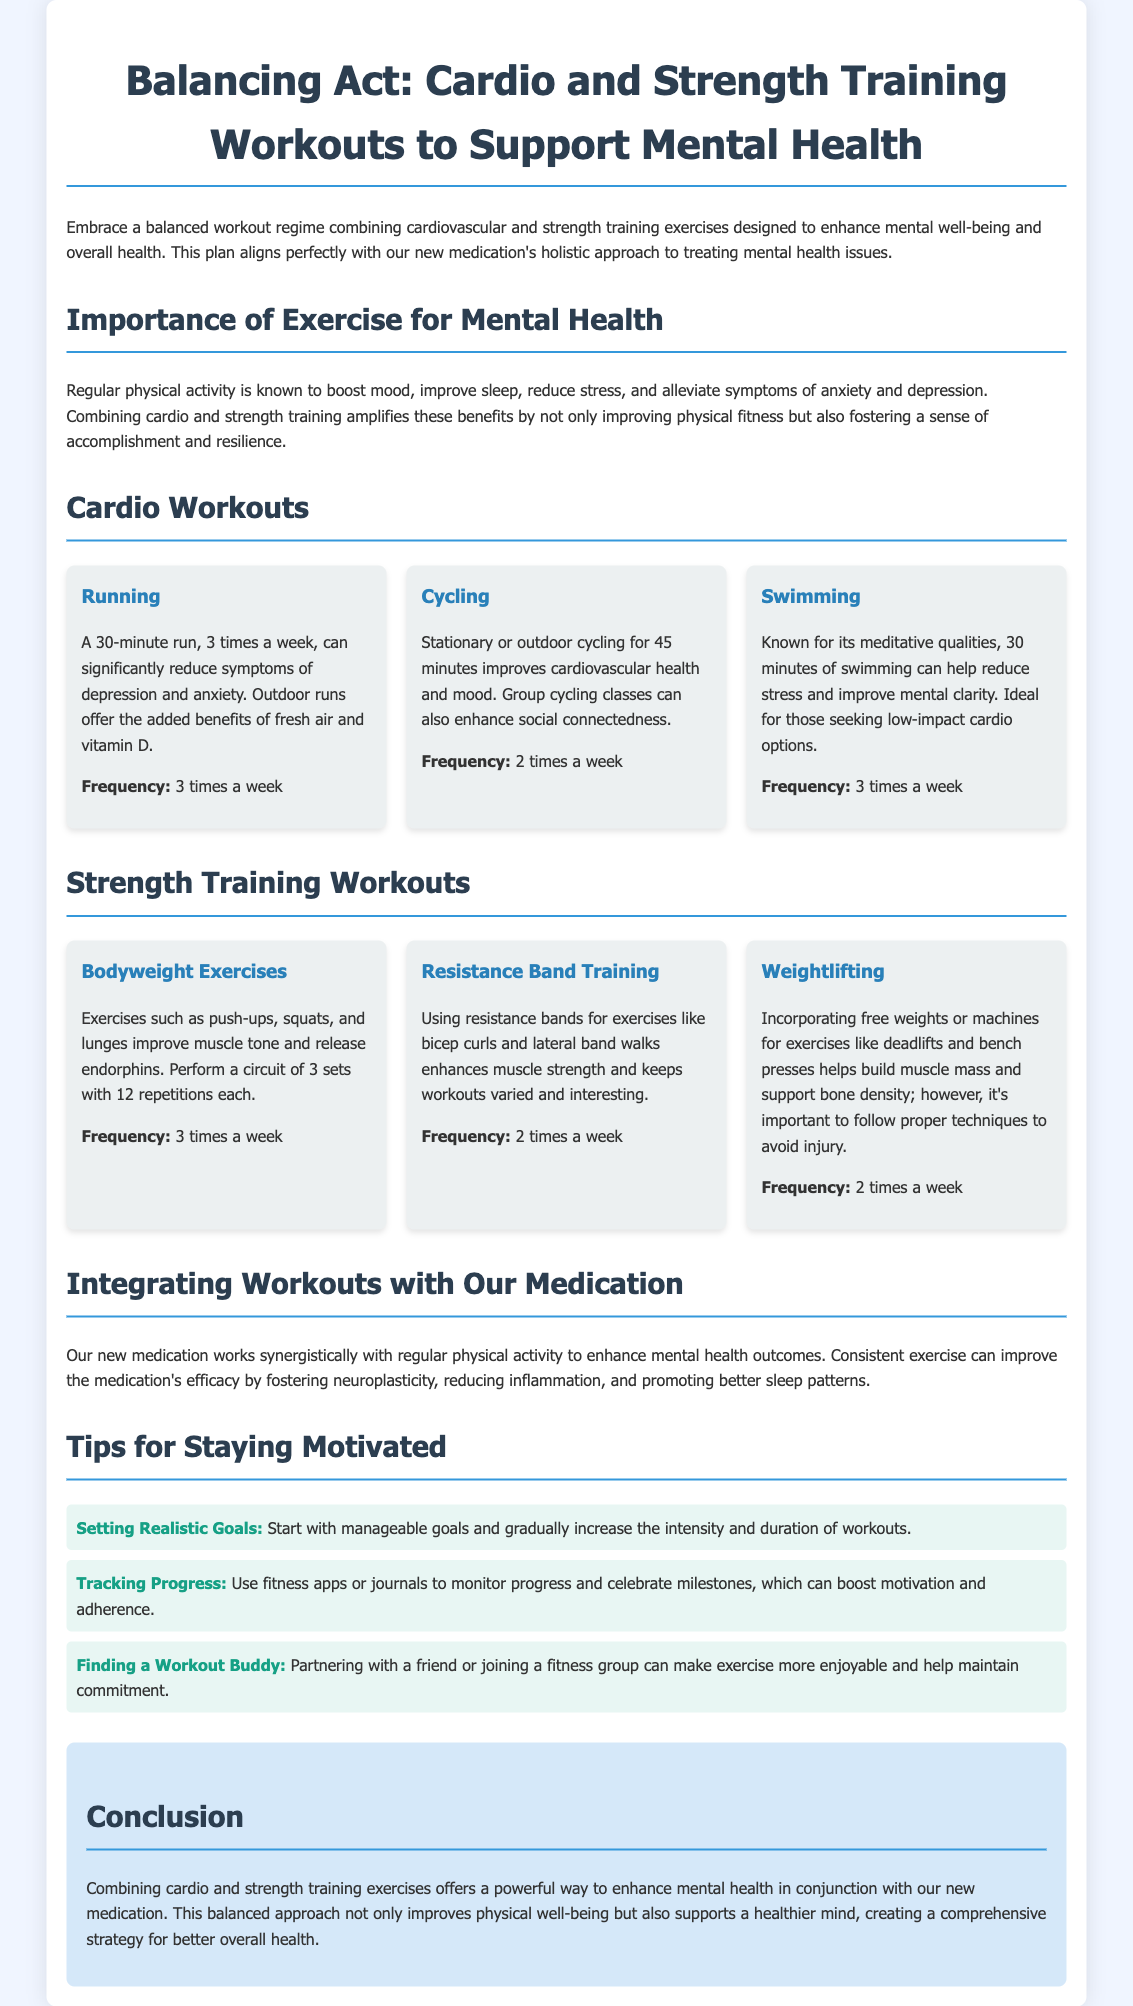What is the title of the document? The title is presented prominently at the top of the document, providing a clear subject focus.
Answer: Balancing Act: Cardio and Strength Training for Mental Health How many times a week should one run? The document specifies the recommended frequency for running as part of the cardio workouts.
Answer: 3 times a week What type of training is suggested twice a week? The frequency of resistance band training is noted in the strength training section of the document.
Answer: Resistance Band Training What is the suggested duration for swimming workouts? The document specifies how long swimming workouts should last in order to be effective.
Answer: 30 minutes What benefit does exercise have on Mental Health according to the document? The document lists several benefits of exercise for mental health, highlighting positive effects on mood and stress.
Answer: Boosts mood What is a recommended strategy to stay motivated? The document provides tips for motivation, suggesting specific actions to maintain commitment to the workout plan.
Answer: Finding a Workout Buddy How many exercises are suggested in the Bodyweight Exercises section? The details provided about bodyweight exercises can help determine the variety mentioned in that section.
Answer: 3 What holistic approach is mentioned in the document? The document discusses the connection between physical activity and outcomes related to mental health, including medication.
Answer: Our new medication's holistic approach to treating mental health issues What type of workouts does the document emphasize? The document focuses on specific types of workouts aimed at improving mental health.
Answer: Cardio and Strength Training 